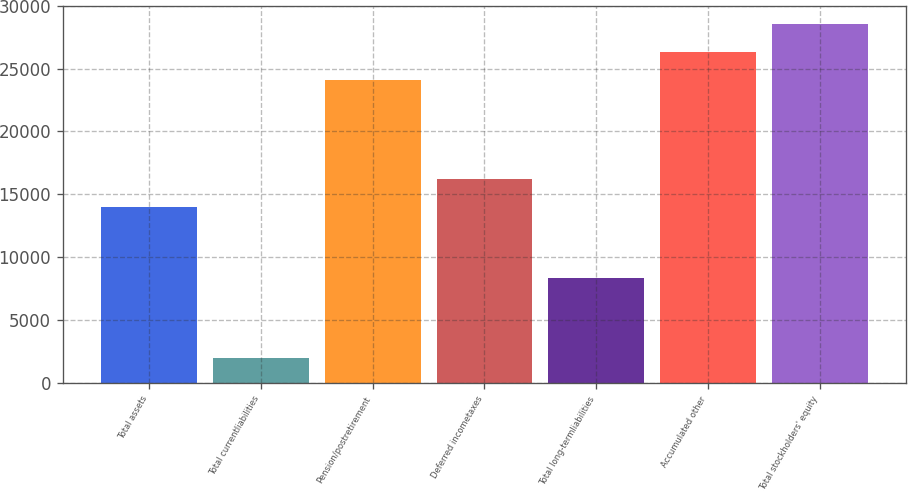Convert chart. <chart><loc_0><loc_0><loc_500><loc_500><bar_chart><fcel>Total assets<fcel>Total currentliabilities<fcel>Pension/postretirement<fcel>Deferred incometaxes<fcel>Total long-termliabilities<fcel>Accumulated other<fcel>Total stockholders' equity<nl><fcel>13961<fcel>2004<fcel>24117<fcel>16194.1<fcel>8370<fcel>26350.1<fcel>28583.2<nl></chart> 